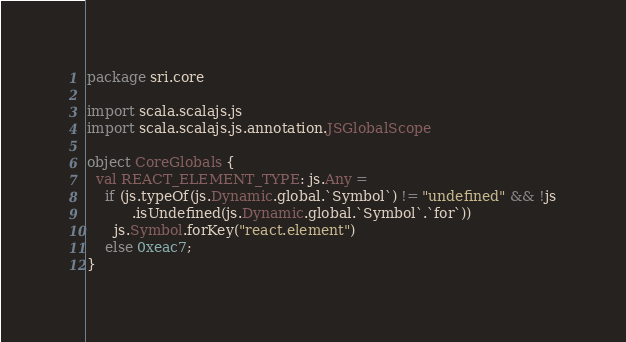Convert code to text. <code><loc_0><loc_0><loc_500><loc_500><_Scala_>package sri.core

import scala.scalajs.js
import scala.scalajs.js.annotation.JSGlobalScope

object CoreGlobals {
  val REACT_ELEMENT_TYPE: js.Any =
    if (js.typeOf(js.Dynamic.global.`Symbol`) != "undefined" && !js
          .isUndefined(js.Dynamic.global.`Symbol`.`for`))
      js.Symbol.forKey("react.element")
    else 0xeac7;
}
</code> 